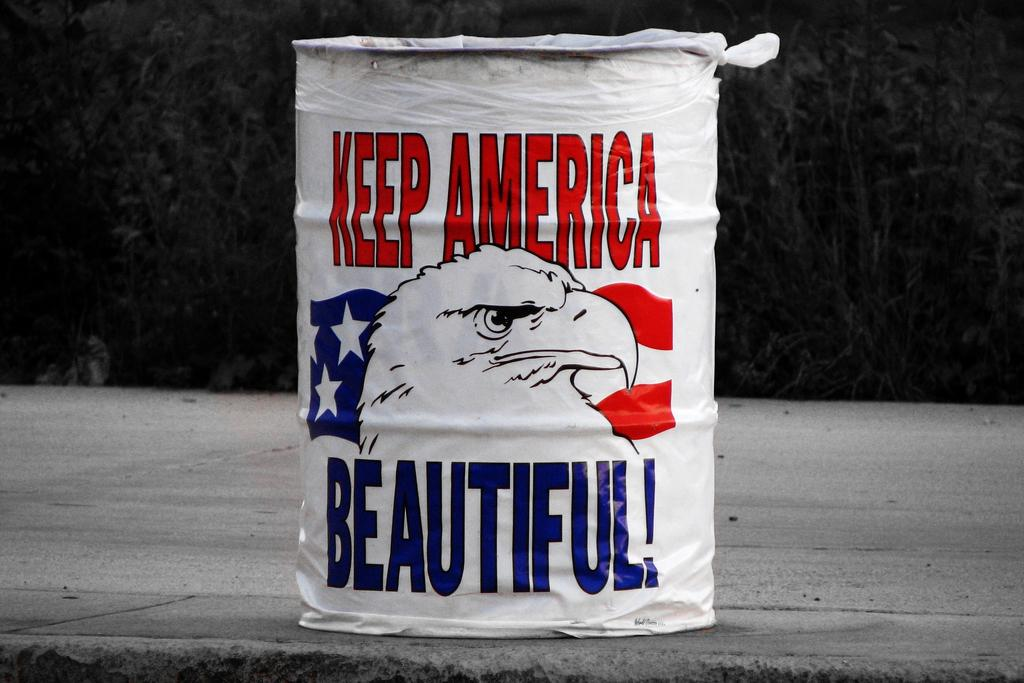<image>
Provide a brief description of the given image. A container with an eagle on it also says keep America beautiful. 